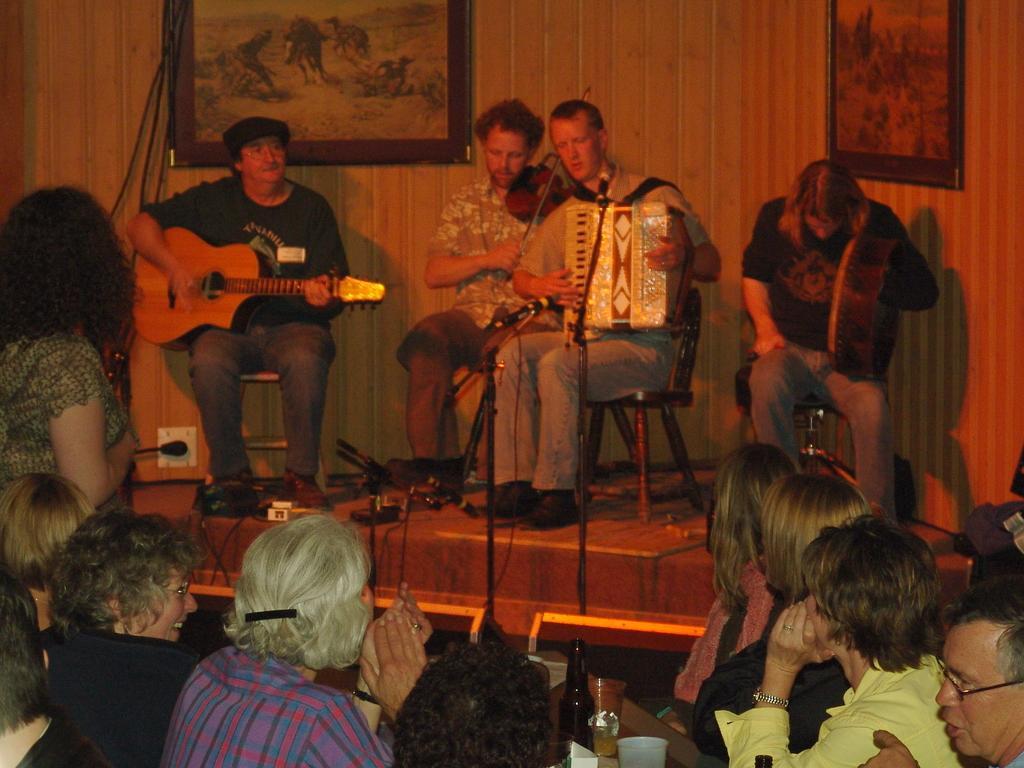In one or two sentences, can you explain what this image depicts? This is a picture taken in a room, there are the four people sitting on a chair and performing the music with different music instruments. In front of this people these are the audience who are watching their performance. Background of this four people is a wall on the wall there are the photo frames. 